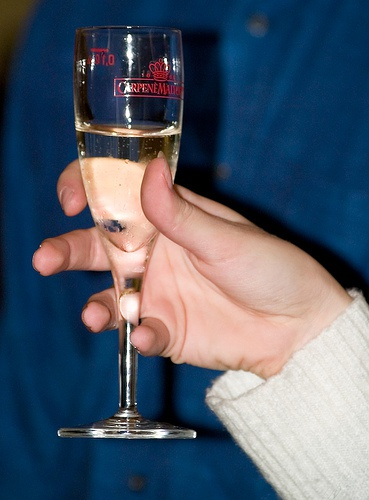Describe the objects in this image and their specific colors. I can see people in black, lightgray, lightpink, pink, and salmon tones and wine glass in black, navy, lightgray, and gray tones in this image. 